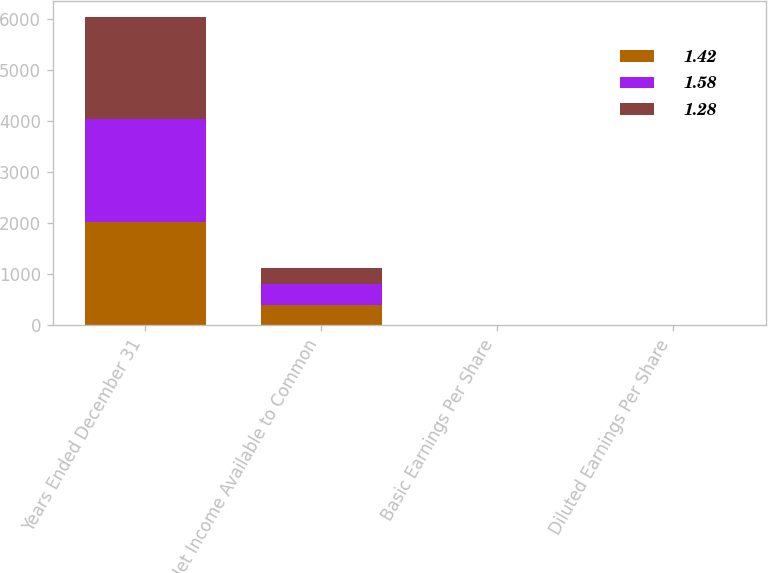<chart> <loc_0><loc_0><loc_500><loc_500><stacked_bar_chart><ecel><fcel>Years Ended December 31<fcel>Net Income Available to Common<fcel>Basic Earnings Per Share<fcel>Diluted Earnings Per Share<nl><fcel>1.42<fcel>2012<fcel>382<fcel>1.46<fcel>1.42<nl><fcel>1.58<fcel>2011<fcel>415<fcel>1.66<fcel>1.58<nl><fcel>1.28<fcel>2010<fcel>324<fcel>1.4<fcel>1.28<nl></chart> 